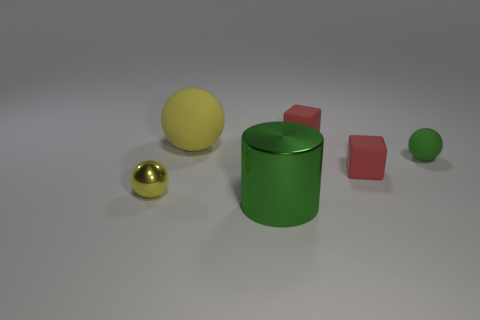Add 1 large blue rubber blocks. How many objects exist? 7 Subtract all cylinders. How many objects are left? 5 Subtract 0 cyan spheres. How many objects are left? 6 Subtract all gray rubber blocks. Subtract all green metallic cylinders. How many objects are left? 5 Add 5 rubber spheres. How many rubber spheres are left? 7 Add 3 yellow matte things. How many yellow matte things exist? 4 